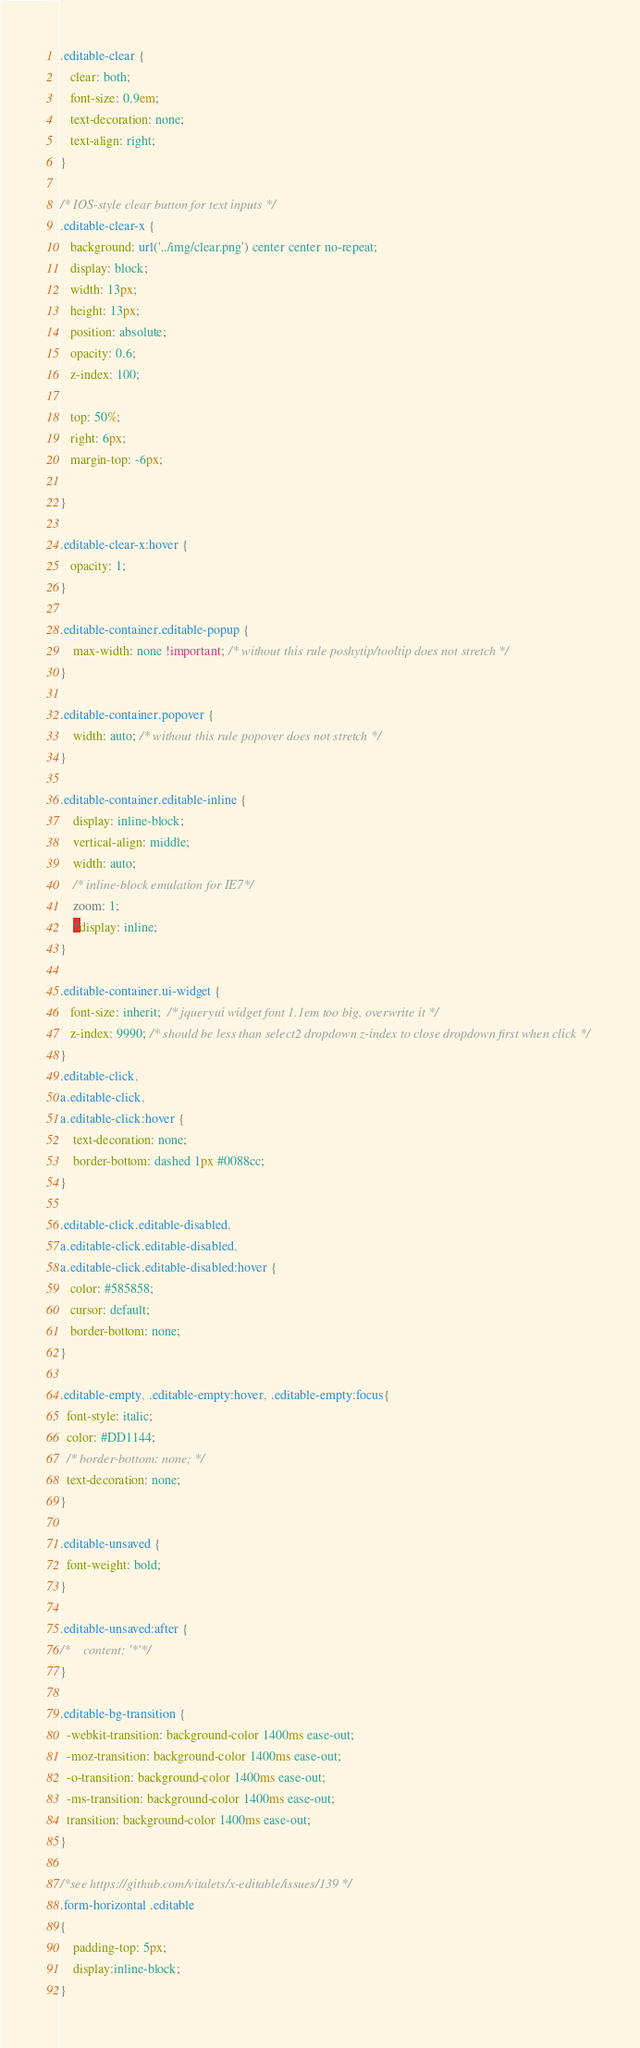Convert code to text. <code><loc_0><loc_0><loc_500><loc_500><_CSS_>.editable-clear {
   clear: both;
   font-size: 0.9em;
   text-decoration: none;
   text-align: right;
}

/* IOS-style clear button for text inputs */
.editable-clear-x {
   background: url('../img/clear.png') center center no-repeat;
   display: block;
   width: 13px;    
   height: 13px;
   position: absolute;
   opacity: 0.6;
   z-index: 100;
   
   top: 50%;
   right: 6px;
   margin-top: -6px;
   
}

.editable-clear-x:hover {
   opacity: 1;
}

.editable-container.editable-popup {
    max-width: none !important; /* without this rule poshytip/tooltip does not stretch */
}  

.editable-container.popover {
    width: auto; /* without this rule popover does not stretch */
}

.editable-container.editable-inline {
    display: inline-block; 
    vertical-align: middle;
    width: auto;
    /* inline-block emulation for IE7*/
    zoom: 1; 
    *display: inline;    
}

.editable-container.ui-widget {
   font-size: inherit;  /* jqueryui widget font 1.1em too big, overwrite it */
   z-index: 9990; /* should be less than select2 dropdown z-index to close dropdown first when click */
}
.editable-click, 
a.editable-click, 
a.editable-click:hover {
    text-decoration: none;
    border-bottom: dashed 1px #0088cc;
}

.editable-click.editable-disabled, 
a.editable-click.editable-disabled, 
a.editable-click.editable-disabled:hover {
   color: #585858;  
   cursor: default;
   border-bottom: none;
}

.editable-empty, .editable-empty:hover, .editable-empty:focus{
  font-style: italic; 
  color: #DD1144;  
  /* border-bottom: none; */
  text-decoration: none;
}

.editable-unsaved {
  font-weight: bold; 
}

.editable-unsaved:after {
/*    content: '*'*/
}

.editable-bg-transition {
  -webkit-transition: background-color 1400ms ease-out;
  -moz-transition: background-color 1400ms ease-out;
  -o-transition: background-color 1400ms ease-out;
  -ms-transition: background-color 1400ms ease-out;
  transition: background-color 1400ms ease-out;  
}

/*see https://github.com/vitalets/x-editable/issues/139 */
.form-horizontal .editable
{ 
    padding-top: 5px;
    display:inline-block;
}

</code> 